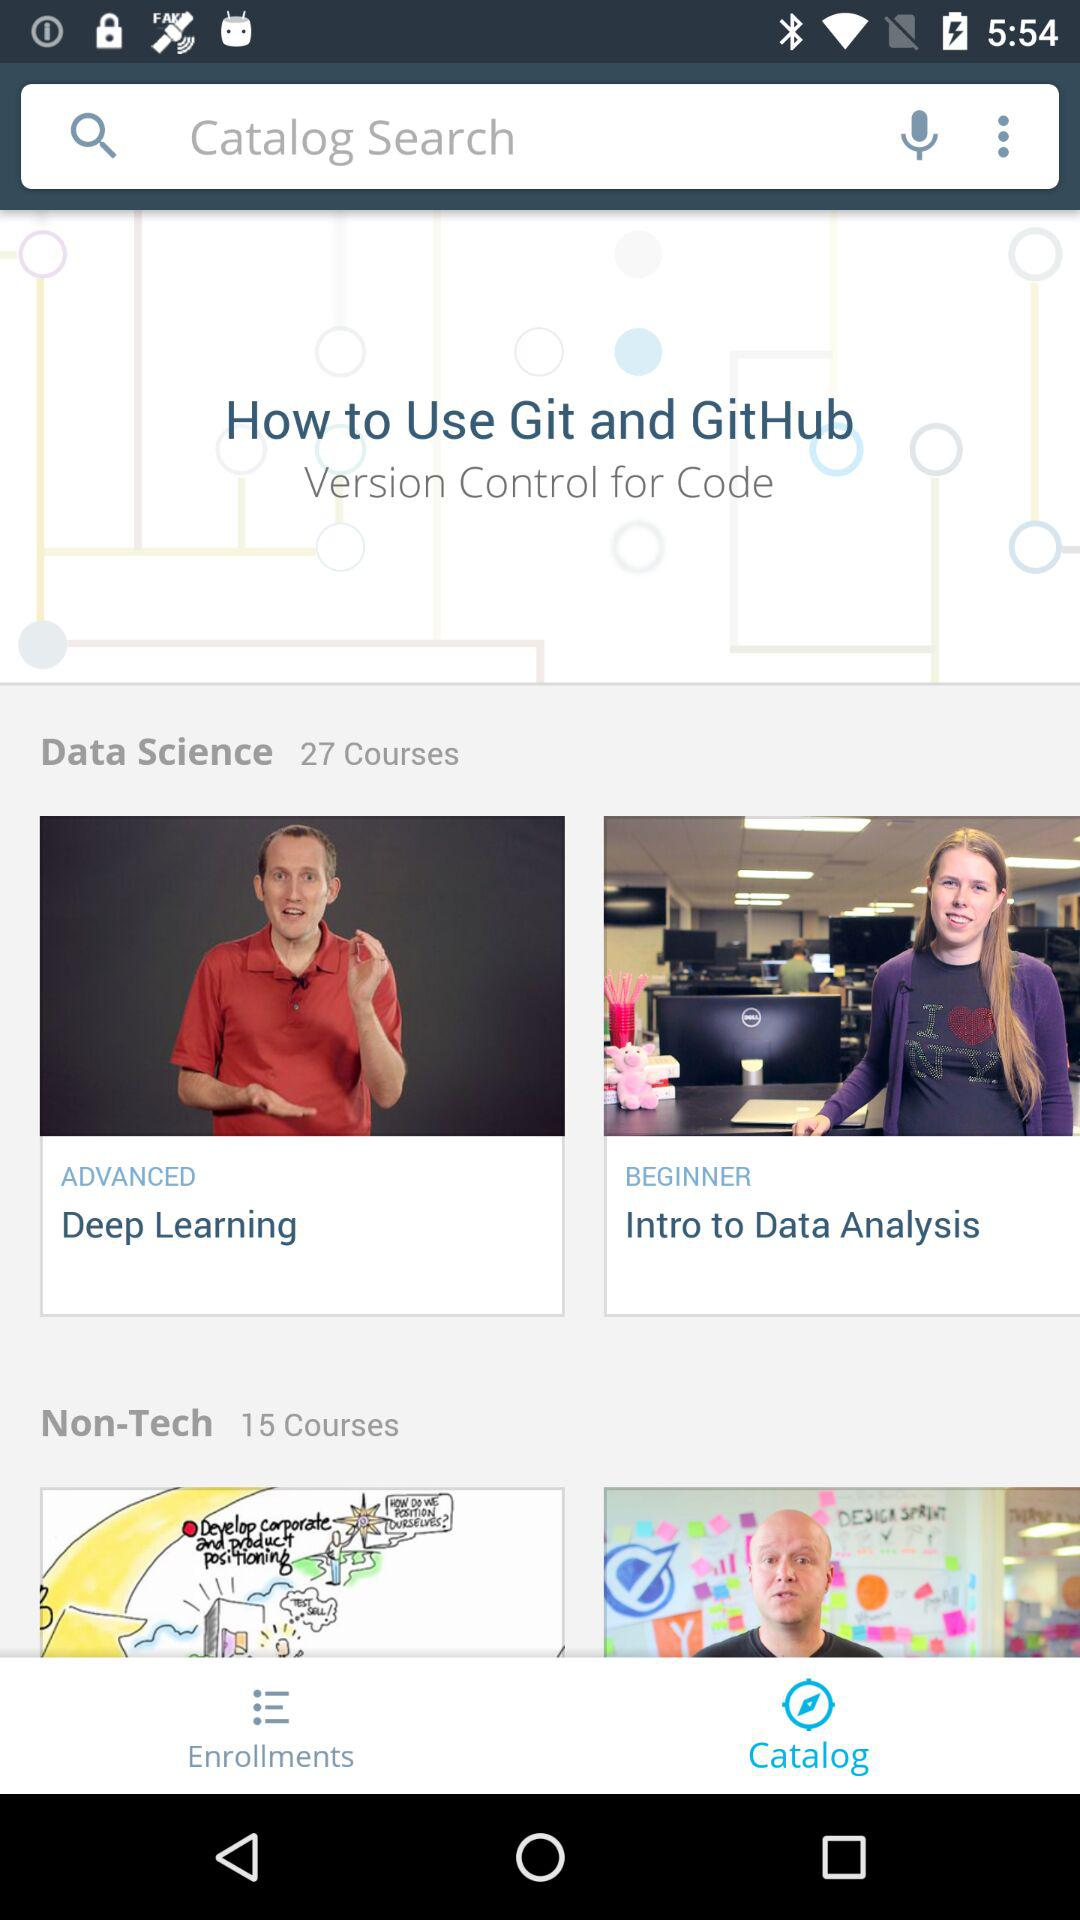Is the "Deep Learning" course for advanced or beginners? The "Deep Learning" course is for advanced. 